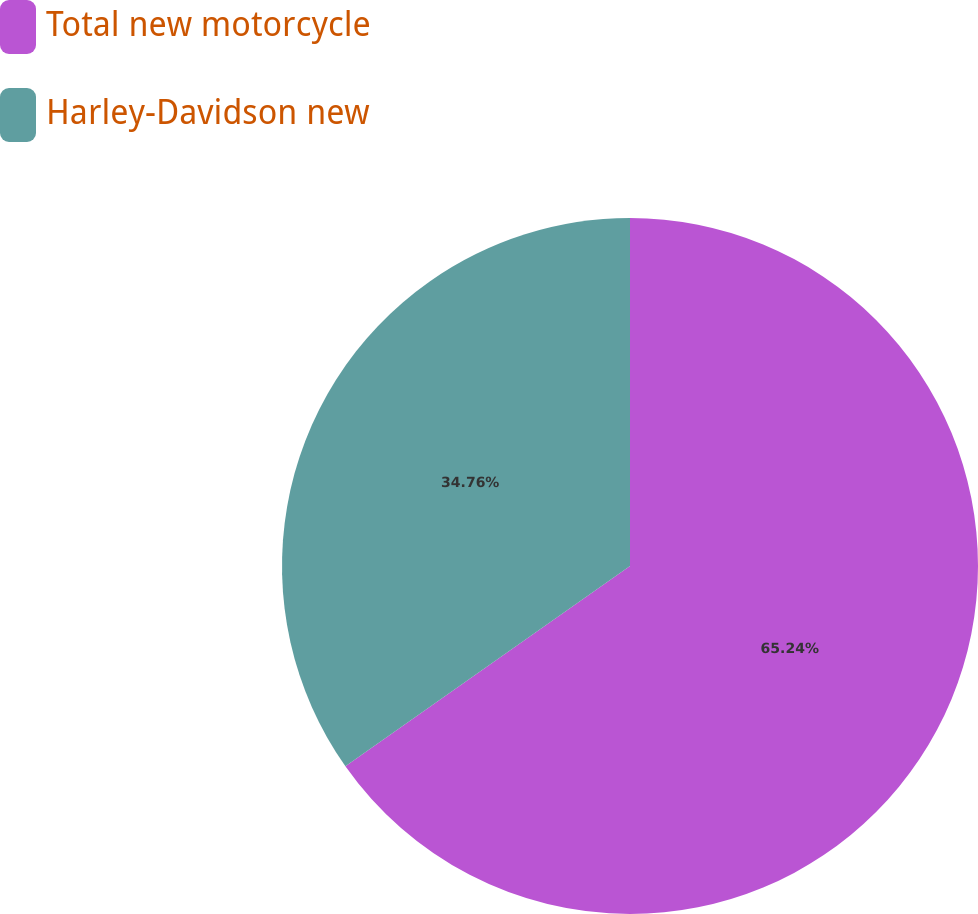Convert chart to OTSL. <chart><loc_0><loc_0><loc_500><loc_500><pie_chart><fcel>Total new motorcycle<fcel>Harley-Davidson new<nl><fcel>65.24%<fcel>34.76%<nl></chart> 